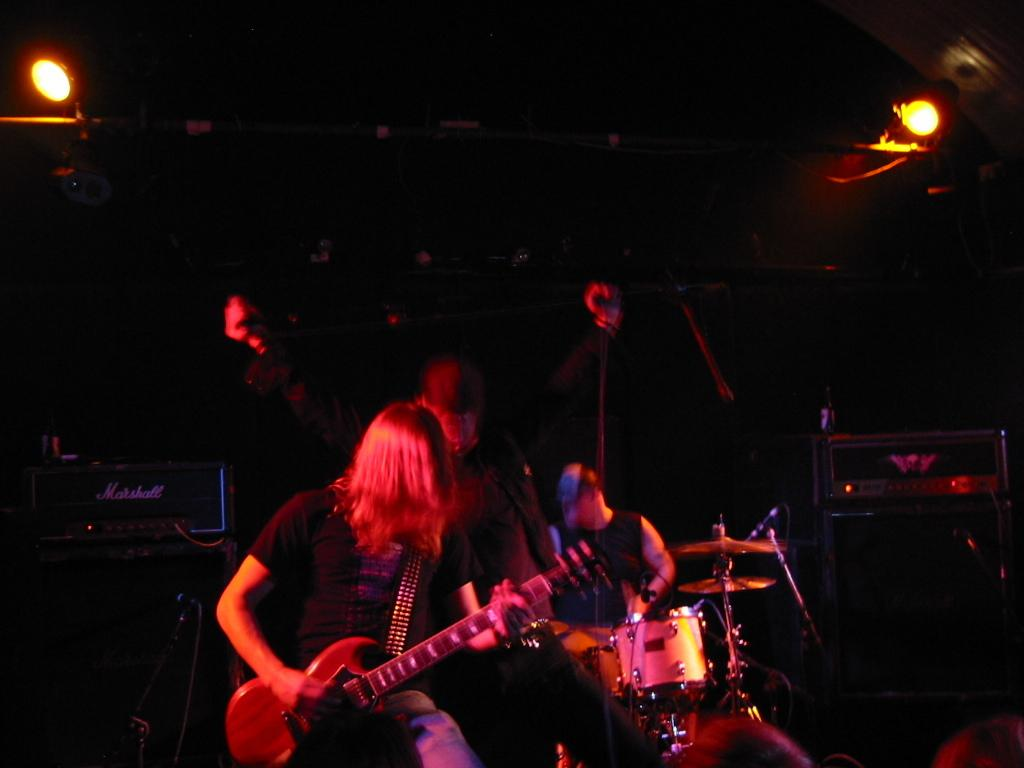How many people are in the image? There are three persons in the image. What are two of the persons doing in the image? Two of the persons are holding musical instruments. What is the third person doing in the image? One person is standing without a musical instrument. What can be seen in the background of the image? There are lights visible in the background of the image. What type of zipper can be seen on the person's clothing in the image? There is no zipper visible on any person's clothing in the image. What type of care is being provided to the musical instruments in the image? There is no indication of care being provided to the musical instruments in the image; they are simply being held by two of the persons. 